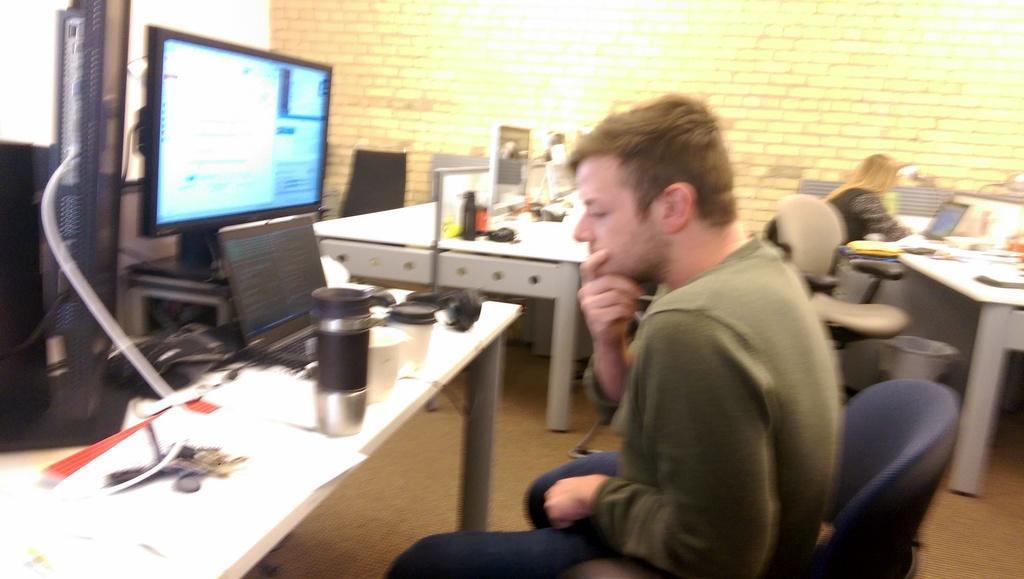Could you give a brief overview of what you see in this image? On the background we can see a wall with bricks. Here we can see few persons sitting on chairs in front of a table and on the table we can see laptops, computer, bottle, cups. This is a trash bin. 